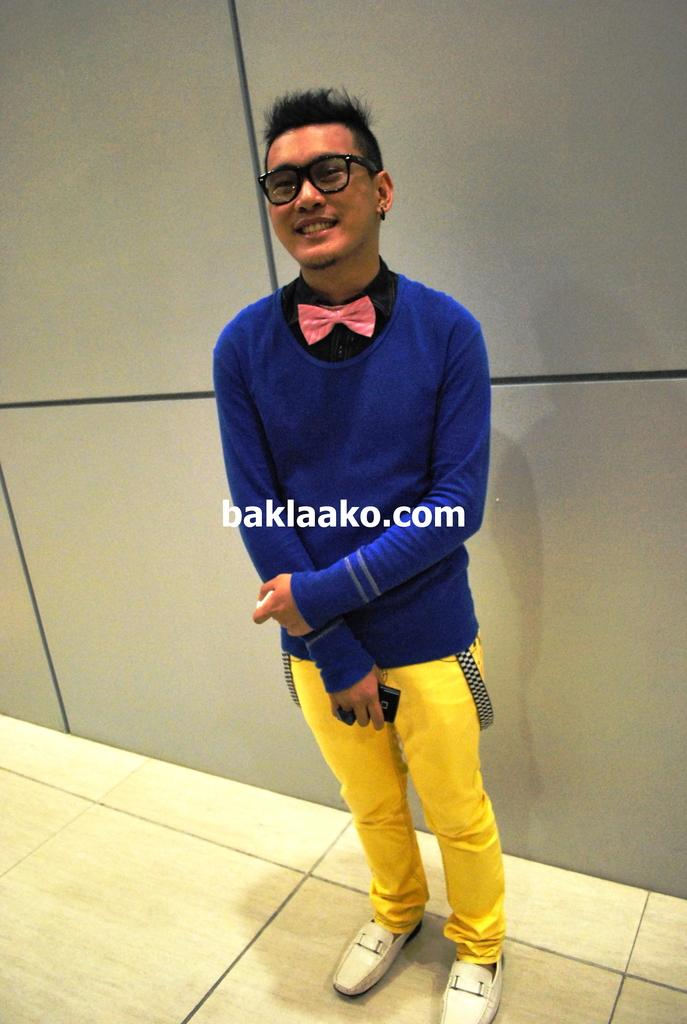What is the main subject of the image? There is a man in the image. What is the man wearing? The man is wearing a blue t-shirt. Where is the man located in the image? The man is standing on the floor. What is behind the man in the image? There is a wall behind the man. How many kittens are sitting on the prison bars in the image? There are no kittens or prison bars present in the image. 